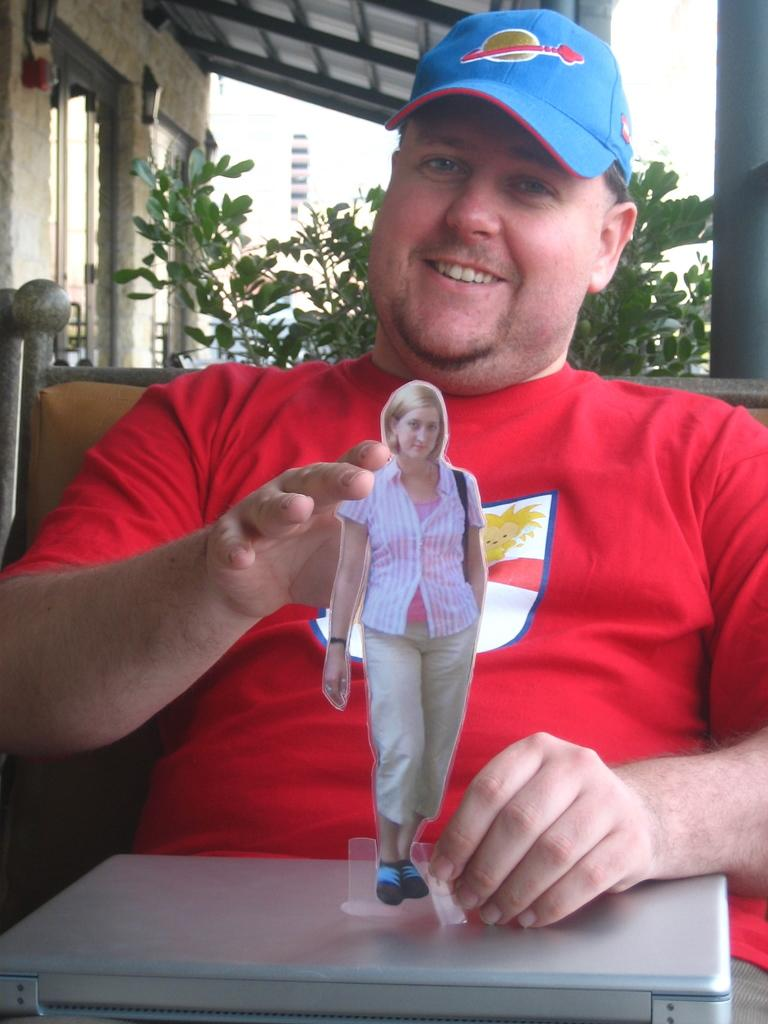Who is present in the image? There is a man in the image. What is the man wearing? The man is wearing a red t-shirt. What is the man doing in the image? The man is sitting on a chair. What can be seen in the background of the image? There is a green plant in the background of the image. What structure is visible in the top of the image? There is a shed visible in the top of the image. What type of volleyball game is being played in the image? There is no volleyball game present in the image; it features a man sitting on a chair wearing a red t-shirt. How many basketballs are visible in the image? There are no basketballs present in the image. 